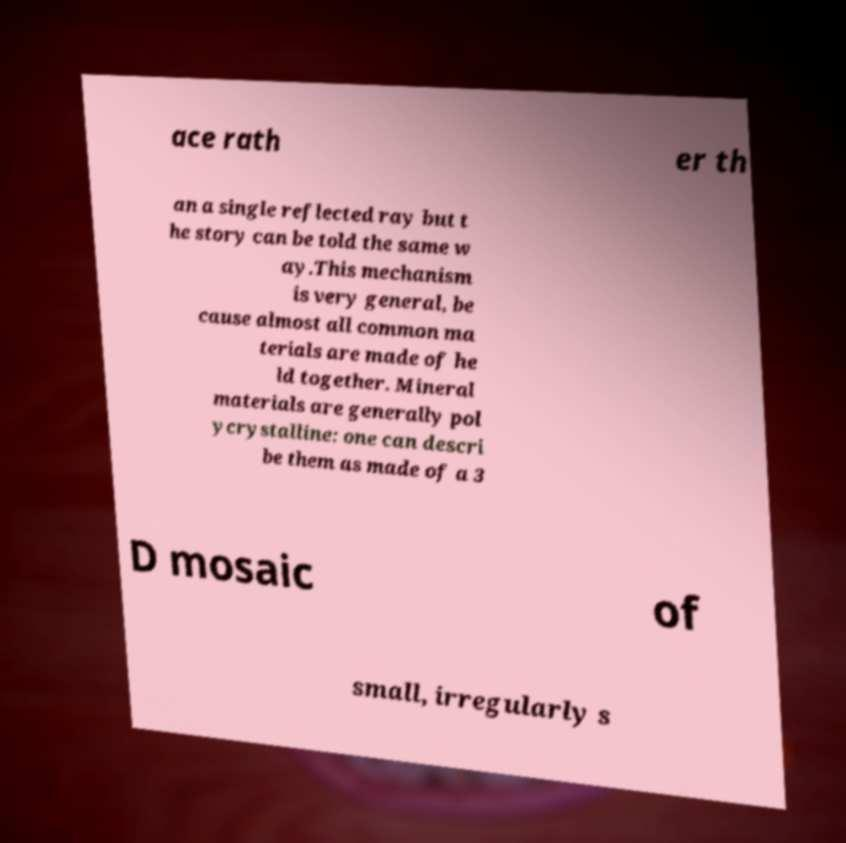Please identify and transcribe the text found in this image. ace rath er th an a single reflected ray but t he story can be told the same w ay.This mechanism is very general, be cause almost all common ma terials are made of he ld together. Mineral materials are generally pol ycrystalline: one can descri be them as made of a 3 D mosaic of small, irregularly s 